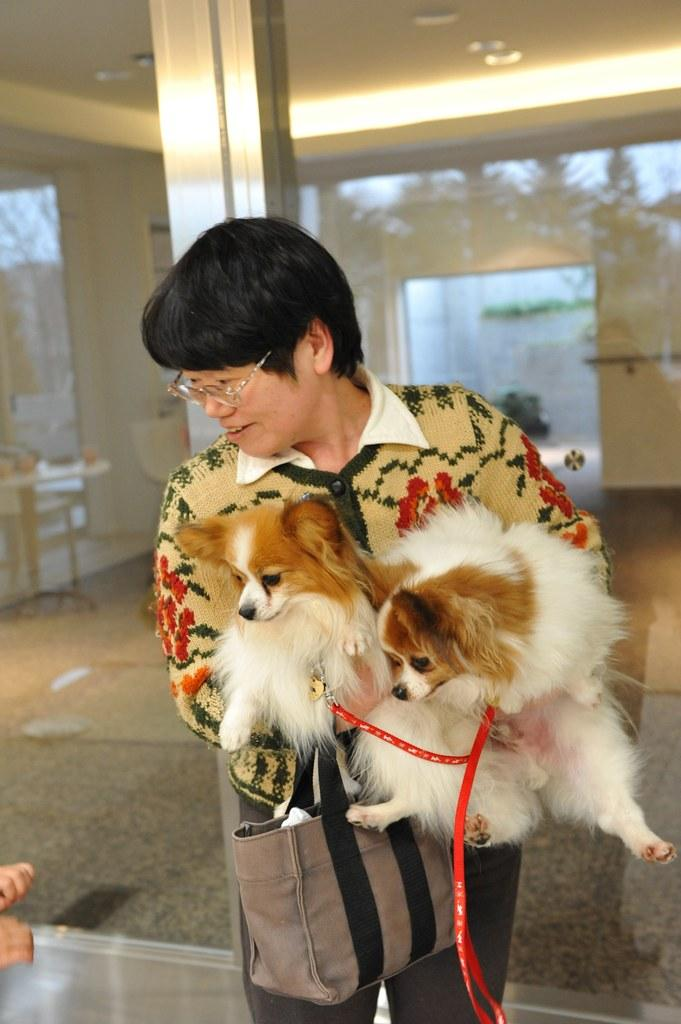What is the main subject of the image? The main subject of the image is a man. What is the man doing in the image? The man is standing and holding puppies in his hands. What type of connection can be seen between the man and the clover in the image? There is no clover present in the image, so there is no connection between the man and clover. 